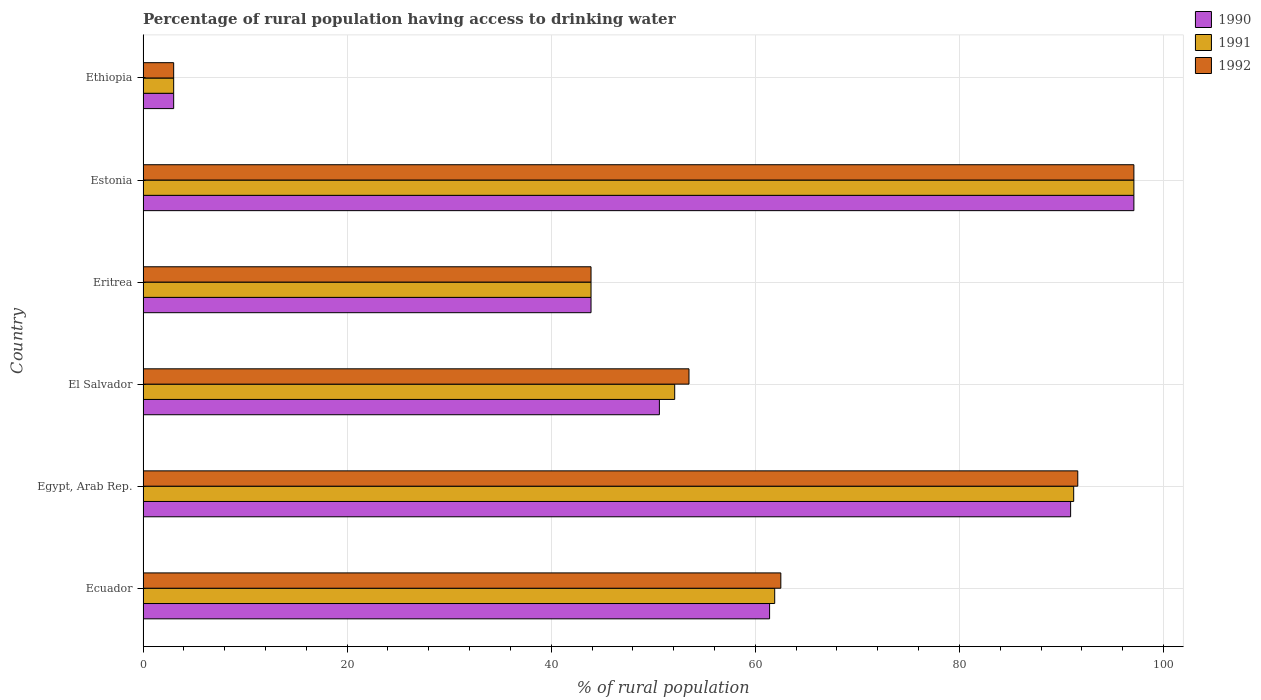How many groups of bars are there?
Offer a terse response. 6. Are the number of bars on each tick of the Y-axis equal?
Ensure brevity in your answer.  Yes. How many bars are there on the 3rd tick from the bottom?
Make the answer very short. 3. What is the label of the 3rd group of bars from the top?
Provide a short and direct response. Eritrea. In how many cases, is the number of bars for a given country not equal to the number of legend labels?
Give a very brief answer. 0. What is the percentage of rural population having access to drinking water in 1992 in Estonia?
Give a very brief answer. 97.1. Across all countries, what is the maximum percentage of rural population having access to drinking water in 1992?
Your answer should be very brief. 97.1. In which country was the percentage of rural population having access to drinking water in 1991 maximum?
Offer a terse response. Estonia. In which country was the percentage of rural population having access to drinking water in 1992 minimum?
Keep it short and to the point. Ethiopia. What is the total percentage of rural population having access to drinking water in 1990 in the graph?
Offer a terse response. 346.9. What is the difference between the percentage of rural population having access to drinking water in 1990 in Eritrea and that in Ethiopia?
Ensure brevity in your answer.  40.9. What is the difference between the percentage of rural population having access to drinking water in 1992 in El Salvador and the percentage of rural population having access to drinking water in 1990 in Eritrea?
Provide a succinct answer. 9.6. What is the average percentage of rural population having access to drinking water in 1991 per country?
Your response must be concise. 58.2. What is the difference between the percentage of rural population having access to drinking water in 1990 and percentage of rural population having access to drinking water in 1992 in Egypt, Arab Rep.?
Provide a short and direct response. -0.7. What is the ratio of the percentage of rural population having access to drinking water in 1992 in El Salvador to that in Estonia?
Your response must be concise. 0.55. Is the difference between the percentage of rural population having access to drinking water in 1990 in Eritrea and Ethiopia greater than the difference between the percentage of rural population having access to drinking water in 1992 in Eritrea and Ethiopia?
Provide a succinct answer. No. What is the difference between the highest and the lowest percentage of rural population having access to drinking water in 1992?
Provide a short and direct response. 94.1. Is the sum of the percentage of rural population having access to drinking water in 1991 in Egypt, Arab Rep. and Ethiopia greater than the maximum percentage of rural population having access to drinking water in 1992 across all countries?
Your response must be concise. No. What does the 2nd bar from the bottom in El Salvador represents?
Offer a terse response. 1991. Are the values on the major ticks of X-axis written in scientific E-notation?
Your answer should be compact. No. How are the legend labels stacked?
Provide a short and direct response. Vertical. What is the title of the graph?
Offer a terse response. Percentage of rural population having access to drinking water. Does "1960" appear as one of the legend labels in the graph?
Provide a succinct answer. No. What is the label or title of the X-axis?
Your response must be concise. % of rural population. What is the % of rural population in 1990 in Ecuador?
Keep it short and to the point. 61.4. What is the % of rural population of 1991 in Ecuador?
Your response must be concise. 61.9. What is the % of rural population of 1992 in Ecuador?
Offer a terse response. 62.5. What is the % of rural population in 1990 in Egypt, Arab Rep.?
Your response must be concise. 90.9. What is the % of rural population of 1991 in Egypt, Arab Rep.?
Offer a very short reply. 91.2. What is the % of rural population of 1992 in Egypt, Arab Rep.?
Offer a terse response. 91.6. What is the % of rural population of 1990 in El Salvador?
Your answer should be compact. 50.6. What is the % of rural population of 1991 in El Salvador?
Make the answer very short. 52.1. What is the % of rural population in 1992 in El Salvador?
Offer a terse response. 53.5. What is the % of rural population in 1990 in Eritrea?
Your response must be concise. 43.9. What is the % of rural population of 1991 in Eritrea?
Your answer should be very brief. 43.9. What is the % of rural population in 1992 in Eritrea?
Provide a succinct answer. 43.9. What is the % of rural population of 1990 in Estonia?
Ensure brevity in your answer.  97.1. What is the % of rural population of 1991 in Estonia?
Ensure brevity in your answer.  97.1. What is the % of rural population of 1992 in Estonia?
Your answer should be very brief. 97.1. What is the % of rural population in 1991 in Ethiopia?
Your answer should be very brief. 3. Across all countries, what is the maximum % of rural population of 1990?
Make the answer very short. 97.1. Across all countries, what is the maximum % of rural population in 1991?
Your answer should be compact. 97.1. Across all countries, what is the maximum % of rural population in 1992?
Make the answer very short. 97.1. Across all countries, what is the minimum % of rural population in 1991?
Offer a very short reply. 3. Across all countries, what is the minimum % of rural population in 1992?
Your response must be concise. 3. What is the total % of rural population in 1990 in the graph?
Offer a terse response. 346.9. What is the total % of rural population of 1991 in the graph?
Provide a succinct answer. 349.2. What is the total % of rural population in 1992 in the graph?
Your answer should be compact. 351.6. What is the difference between the % of rural population of 1990 in Ecuador and that in Egypt, Arab Rep.?
Your answer should be compact. -29.5. What is the difference between the % of rural population in 1991 in Ecuador and that in Egypt, Arab Rep.?
Your answer should be very brief. -29.3. What is the difference between the % of rural population of 1992 in Ecuador and that in Egypt, Arab Rep.?
Offer a very short reply. -29.1. What is the difference between the % of rural population of 1990 in Ecuador and that in El Salvador?
Your answer should be very brief. 10.8. What is the difference between the % of rural population of 1991 in Ecuador and that in El Salvador?
Keep it short and to the point. 9.8. What is the difference between the % of rural population in 1992 in Ecuador and that in El Salvador?
Make the answer very short. 9. What is the difference between the % of rural population of 1992 in Ecuador and that in Eritrea?
Your response must be concise. 18.6. What is the difference between the % of rural population of 1990 in Ecuador and that in Estonia?
Your answer should be compact. -35.7. What is the difference between the % of rural population in 1991 in Ecuador and that in Estonia?
Offer a very short reply. -35.2. What is the difference between the % of rural population of 1992 in Ecuador and that in Estonia?
Keep it short and to the point. -34.6. What is the difference between the % of rural population of 1990 in Ecuador and that in Ethiopia?
Your answer should be very brief. 58.4. What is the difference between the % of rural population of 1991 in Ecuador and that in Ethiopia?
Make the answer very short. 58.9. What is the difference between the % of rural population of 1992 in Ecuador and that in Ethiopia?
Your answer should be compact. 59.5. What is the difference between the % of rural population in 1990 in Egypt, Arab Rep. and that in El Salvador?
Provide a succinct answer. 40.3. What is the difference between the % of rural population of 1991 in Egypt, Arab Rep. and that in El Salvador?
Provide a succinct answer. 39.1. What is the difference between the % of rural population of 1992 in Egypt, Arab Rep. and that in El Salvador?
Offer a very short reply. 38.1. What is the difference between the % of rural population of 1991 in Egypt, Arab Rep. and that in Eritrea?
Your response must be concise. 47.3. What is the difference between the % of rural population in 1992 in Egypt, Arab Rep. and that in Eritrea?
Your answer should be compact. 47.7. What is the difference between the % of rural population in 1991 in Egypt, Arab Rep. and that in Estonia?
Provide a short and direct response. -5.9. What is the difference between the % of rural population of 1992 in Egypt, Arab Rep. and that in Estonia?
Your response must be concise. -5.5. What is the difference between the % of rural population of 1990 in Egypt, Arab Rep. and that in Ethiopia?
Offer a very short reply. 87.9. What is the difference between the % of rural population of 1991 in Egypt, Arab Rep. and that in Ethiopia?
Your answer should be very brief. 88.2. What is the difference between the % of rural population in 1992 in Egypt, Arab Rep. and that in Ethiopia?
Offer a very short reply. 88.6. What is the difference between the % of rural population of 1990 in El Salvador and that in Eritrea?
Provide a short and direct response. 6.7. What is the difference between the % of rural population in 1990 in El Salvador and that in Estonia?
Your answer should be compact. -46.5. What is the difference between the % of rural population in 1991 in El Salvador and that in Estonia?
Your response must be concise. -45. What is the difference between the % of rural population in 1992 in El Salvador and that in Estonia?
Provide a short and direct response. -43.6. What is the difference between the % of rural population of 1990 in El Salvador and that in Ethiopia?
Your response must be concise. 47.6. What is the difference between the % of rural population of 1991 in El Salvador and that in Ethiopia?
Provide a short and direct response. 49.1. What is the difference between the % of rural population of 1992 in El Salvador and that in Ethiopia?
Your response must be concise. 50.5. What is the difference between the % of rural population in 1990 in Eritrea and that in Estonia?
Provide a succinct answer. -53.2. What is the difference between the % of rural population of 1991 in Eritrea and that in Estonia?
Make the answer very short. -53.2. What is the difference between the % of rural population in 1992 in Eritrea and that in Estonia?
Keep it short and to the point. -53.2. What is the difference between the % of rural population of 1990 in Eritrea and that in Ethiopia?
Your answer should be compact. 40.9. What is the difference between the % of rural population of 1991 in Eritrea and that in Ethiopia?
Offer a terse response. 40.9. What is the difference between the % of rural population of 1992 in Eritrea and that in Ethiopia?
Make the answer very short. 40.9. What is the difference between the % of rural population of 1990 in Estonia and that in Ethiopia?
Offer a terse response. 94.1. What is the difference between the % of rural population in 1991 in Estonia and that in Ethiopia?
Your answer should be very brief. 94.1. What is the difference between the % of rural population of 1992 in Estonia and that in Ethiopia?
Make the answer very short. 94.1. What is the difference between the % of rural population of 1990 in Ecuador and the % of rural population of 1991 in Egypt, Arab Rep.?
Keep it short and to the point. -29.8. What is the difference between the % of rural population of 1990 in Ecuador and the % of rural population of 1992 in Egypt, Arab Rep.?
Offer a terse response. -30.2. What is the difference between the % of rural population in 1991 in Ecuador and the % of rural population in 1992 in Egypt, Arab Rep.?
Your answer should be very brief. -29.7. What is the difference between the % of rural population in 1990 in Ecuador and the % of rural population in 1991 in El Salvador?
Make the answer very short. 9.3. What is the difference between the % of rural population of 1991 in Ecuador and the % of rural population of 1992 in El Salvador?
Make the answer very short. 8.4. What is the difference between the % of rural population in 1991 in Ecuador and the % of rural population in 1992 in Eritrea?
Offer a terse response. 18. What is the difference between the % of rural population in 1990 in Ecuador and the % of rural population in 1991 in Estonia?
Make the answer very short. -35.7. What is the difference between the % of rural population in 1990 in Ecuador and the % of rural population in 1992 in Estonia?
Ensure brevity in your answer.  -35.7. What is the difference between the % of rural population of 1991 in Ecuador and the % of rural population of 1992 in Estonia?
Your answer should be very brief. -35.2. What is the difference between the % of rural population in 1990 in Ecuador and the % of rural population in 1991 in Ethiopia?
Make the answer very short. 58.4. What is the difference between the % of rural population in 1990 in Ecuador and the % of rural population in 1992 in Ethiopia?
Give a very brief answer. 58.4. What is the difference between the % of rural population in 1991 in Ecuador and the % of rural population in 1992 in Ethiopia?
Your answer should be compact. 58.9. What is the difference between the % of rural population of 1990 in Egypt, Arab Rep. and the % of rural population of 1991 in El Salvador?
Ensure brevity in your answer.  38.8. What is the difference between the % of rural population of 1990 in Egypt, Arab Rep. and the % of rural population of 1992 in El Salvador?
Offer a terse response. 37.4. What is the difference between the % of rural population of 1991 in Egypt, Arab Rep. and the % of rural population of 1992 in El Salvador?
Ensure brevity in your answer.  37.7. What is the difference between the % of rural population of 1991 in Egypt, Arab Rep. and the % of rural population of 1992 in Eritrea?
Your response must be concise. 47.3. What is the difference between the % of rural population in 1990 in Egypt, Arab Rep. and the % of rural population in 1991 in Estonia?
Offer a very short reply. -6.2. What is the difference between the % of rural population of 1990 in Egypt, Arab Rep. and the % of rural population of 1991 in Ethiopia?
Your answer should be compact. 87.9. What is the difference between the % of rural population of 1990 in Egypt, Arab Rep. and the % of rural population of 1992 in Ethiopia?
Keep it short and to the point. 87.9. What is the difference between the % of rural population in 1991 in Egypt, Arab Rep. and the % of rural population in 1992 in Ethiopia?
Your answer should be very brief. 88.2. What is the difference between the % of rural population of 1990 in El Salvador and the % of rural population of 1991 in Eritrea?
Offer a terse response. 6.7. What is the difference between the % of rural population of 1991 in El Salvador and the % of rural population of 1992 in Eritrea?
Provide a succinct answer. 8.2. What is the difference between the % of rural population of 1990 in El Salvador and the % of rural population of 1991 in Estonia?
Your response must be concise. -46.5. What is the difference between the % of rural population in 1990 in El Salvador and the % of rural population in 1992 in Estonia?
Give a very brief answer. -46.5. What is the difference between the % of rural population in 1991 in El Salvador and the % of rural population in 1992 in Estonia?
Offer a terse response. -45. What is the difference between the % of rural population of 1990 in El Salvador and the % of rural population of 1991 in Ethiopia?
Provide a succinct answer. 47.6. What is the difference between the % of rural population of 1990 in El Salvador and the % of rural population of 1992 in Ethiopia?
Offer a very short reply. 47.6. What is the difference between the % of rural population in 1991 in El Salvador and the % of rural population in 1992 in Ethiopia?
Keep it short and to the point. 49.1. What is the difference between the % of rural population in 1990 in Eritrea and the % of rural population in 1991 in Estonia?
Provide a succinct answer. -53.2. What is the difference between the % of rural population in 1990 in Eritrea and the % of rural population in 1992 in Estonia?
Your answer should be compact. -53.2. What is the difference between the % of rural population in 1991 in Eritrea and the % of rural population in 1992 in Estonia?
Keep it short and to the point. -53.2. What is the difference between the % of rural population of 1990 in Eritrea and the % of rural population of 1991 in Ethiopia?
Your response must be concise. 40.9. What is the difference between the % of rural population in 1990 in Eritrea and the % of rural population in 1992 in Ethiopia?
Give a very brief answer. 40.9. What is the difference between the % of rural population in 1991 in Eritrea and the % of rural population in 1992 in Ethiopia?
Offer a very short reply. 40.9. What is the difference between the % of rural population of 1990 in Estonia and the % of rural population of 1991 in Ethiopia?
Keep it short and to the point. 94.1. What is the difference between the % of rural population in 1990 in Estonia and the % of rural population in 1992 in Ethiopia?
Make the answer very short. 94.1. What is the difference between the % of rural population of 1991 in Estonia and the % of rural population of 1992 in Ethiopia?
Give a very brief answer. 94.1. What is the average % of rural population in 1990 per country?
Give a very brief answer. 57.82. What is the average % of rural population of 1991 per country?
Ensure brevity in your answer.  58.2. What is the average % of rural population in 1992 per country?
Your answer should be compact. 58.6. What is the difference between the % of rural population of 1991 and % of rural population of 1992 in Ecuador?
Keep it short and to the point. -0.6. What is the difference between the % of rural population in 1991 and % of rural population in 1992 in El Salvador?
Provide a succinct answer. -1.4. What is the difference between the % of rural population in 1991 and % of rural population in 1992 in Ethiopia?
Provide a succinct answer. 0. What is the ratio of the % of rural population of 1990 in Ecuador to that in Egypt, Arab Rep.?
Keep it short and to the point. 0.68. What is the ratio of the % of rural population in 1991 in Ecuador to that in Egypt, Arab Rep.?
Offer a terse response. 0.68. What is the ratio of the % of rural population of 1992 in Ecuador to that in Egypt, Arab Rep.?
Provide a succinct answer. 0.68. What is the ratio of the % of rural population of 1990 in Ecuador to that in El Salvador?
Your answer should be very brief. 1.21. What is the ratio of the % of rural population of 1991 in Ecuador to that in El Salvador?
Your answer should be compact. 1.19. What is the ratio of the % of rural population in 1992 in Ecuador to that in El Salvador?
Ensure brevity in your answer.  1.17. What is the ratio of the % of rural population in 1990 in Ecuador to that in Eritrea?
Provide a short and direct response. 1.4. What is the ratio of the % of rural population in 1991 in Ecuador to that in Eritrea?
Keep it short and to the point. 1.41. What is the ratio of the % of rural population in 1992 in Ecuador to that in Eritrea?
Give a very brief answer. 1.42. What is the ratio of the % of rural population of 1990 in Ecuador to that in Estonia?
Offer a very short reply. 0.63. What is the ratio of the % of rural population of 1991 in Ecuador to that in Estonia?
Your response must be concise. 0.64. What is the ratio of the % of rural population in 1992 in Ecuador to that in Estonia?
Your answer should be compact. 0.64. What is the ratio of the % of rural population of 1990 in Ecuador to that in Ethiopia?
Your response must be concise. 20.47. What is the ratio of the % of rural population of 1991 in Ecuador to that in Ethiopia?
Make the answer very short. 20.63. What is the ratio of the % of rural population of 1992 in Ecuador to that in Ethiopia?
Offer a very short reply. 20.83. What is the ratio of the % of rural population of 1990 in Egypt, Arab Rep. to that in El Salvador?
Your response must be concise. 1.8. What is the ratio of the % of rural population in 1991 in Egypt, Arab Rep. to that in El Salvador?
Give a very brief answer. 1.75. What is the ratio of the % of rural population in 1992 in Egypt, Arab Rep. to that in El Salvador?
Your response must be concise. 1.71. What is the ratio of the % of rural population in 1990 in Egypt, Arab Rep. to that in Eritrea?
Ensure brevity in your answer.  2.07. What is the ratio of the % of rural population of 1991 in Egypt, Arab Rep. to that in Eritrea?
Ensure brevity in your answer.  2.08. What is the ratio of the % of rural population in 1992 in Egypt, Arab Rep. to that in Eritrea?
Your response must be concise. 2.09. What is the ratio of the % of rural population in 1990 in Egypt, Arab Rep. to that in Estonia?
Keep it short and to the point. 0.94. What is the ratio of the % of rural population in 1991 in Egypt, Arab Rep. to that in Estonia?
Offer a terse response. 0.94. What is the ratio of the % of rural population of 1992 in Egypt, Arab Rep. to that in Estonia?
Provide a short and direct response. 0.94. What is the ratio of the % of rural population of 1990 in Egypt, Arab Rep. to that in Ethiopia?
Offer a very short reply. 30.3. What is the ratio of the % of rural population of 1991 in Egypt, Arab Rep. to that in Ethiopia?
Provide a short and direct response. 30.4. What is the ratio of the % of rural population in 1992 in Egypt, Arab Rep. to that in Ethiopia?
Provide a short and direct response. 30.53. What is the ratio of the % of rural population of 1990 in El Salvador to that in Eritrea?
Your answer should be compact. 1.15. What is the ratio of the % of rural population of 1991 in El Salvador to that in Eritrea?
Your answer should be compact. 1.19. What is the ratio of the % of rural population of 1992 in El Salvador to that in Eritrea?
Give a very brief answer. 1.22. What is the ratio of the % of rural population of 1990 in El Salvador to that in Estonia?
Offer a terse response. 0.52. What is the ratio of the % of rural population in 1991 in El Salvador to that in Estonia?
Your answer should be compact. 0.54. What is the ratio of the % of rural population in 1992 in El Salvador to that in Estonia?
Provide a short and direct response. 0.55. What is the ratio of the % of rural population of 1990 in El Salvador to that in Ethiopia?
Make the answer very short. 16.87. What is the ratio of the % of rural population in 1991 in El Salvador to that in Ethiopia?
Your answer should be compact. 17.37. What is the ratio of the % of rural population of 1992 in El Salvador to that in Ethiopia?
Give a very brief answer. 17.83. What is the ratio of the % of rural population in 1990 in Eritrea to that in Estonia?
Provide a succinct answer. 0.45. What is the ratio of the % of rural population in 1991 in Eritrea to that in Estonia?
Give a very brief answer. 0.45. What is the ratio of the % of rural population in 1992 in Eritrea to that in Estonia?
Provide a short and direct response. 0.45. What is the ratio of the % of rural population in 1990 in Eritrea to that in Ethiopia?
Your answer should be very brief. 14.63. What is the ratio of the % of rural population in 1991 in Eritrea to that in Ethiopia?
Your answer should be compact. 14.63. What is the ratio of the % of rural population in 1992 in Eritrea to that in Ethiopia?
Keep it short and to the point. 14.63. What is the ratio of the % of rural population in 1990 in Estonia to that in Ethiopia?
Provide a succinct answer. 32.37. What is the ratio of the % of rural population in 1991 in Estonia to that in Ethiopia?
Your response must be concise. 32.37. What is the ratio of the % of rural population of 1992 in Estonia to that in Ethiopia?
Your answer should be compact. 32.37. What is the difference between the highest and the second highest % of rural population in 1991?
Make the answer very short. 5.9. What is the difference between the highest and the lowest % of rural population of 1990?
Your answer should be very brief. 94.1. What is the difference between the highest and the lowest % of rural population of 1991?
Provide a succinct answer. 94.1. What is the difference between the highest and the lowest % of rural population of 1992?
Provide a succinct answer. 94.1. 